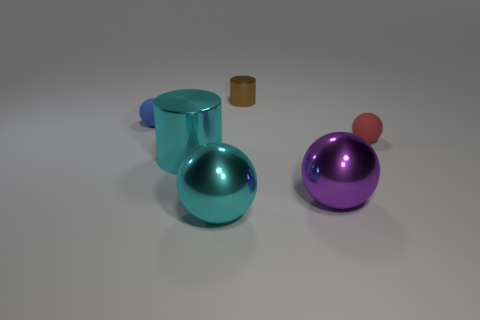Add 1 large cyan metal things. How many objects exist? 7 Subtract all large cyan shiny spheres. How many spheres are left? 3 Subtract all cyan cylinders. How many cylinders are left? 1 Subtract all balls. How many objects are left? 2 Add 6 tiny brown shiny things. How many tiny brown shiny things are left? 7 Add 5 purple metallic objects. How many purple metallic objects exist? 6 Subtract 0 green blocks. How many objects are left? 6 Subtract 1 balls. How many balls are left? 3 Subtract all red balls. Subtract all red cylinders. How many balls are left? 3 Subtract all metallic spheres. Subtract all tiny yellow shiny things. How many objects are left? 4 